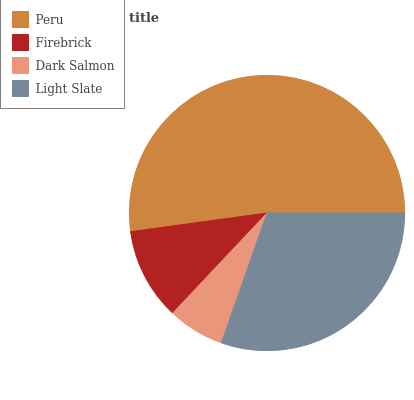Is Dark Salmon the minimum?
Answer yes or no. Yes. Is Peru the maximum?
Answer yes or no. Yes. Is Firebrick the minimum?
Answer yes or no. No. Is Firebrick the maximum?
Answer yes or no. No. Is Peru greater than Firebrick?
Answer yes or no. Yes. Is Firebrick less than Peru?
Answer yes or no. Yes. Is Firebrick greater than Peru?
Answer yes or no. No. Is Peru less than Firebrick?
Answer yes or no. No. Is Light Slate the high median?
Answer yes or no. Yes. Is Firebrick the low median?
Answer yes or no. Yes. Is Firebrick the high median?
Answer yes or no. No. Is Dark Salmon the low median?
Answer yes or no. No. 